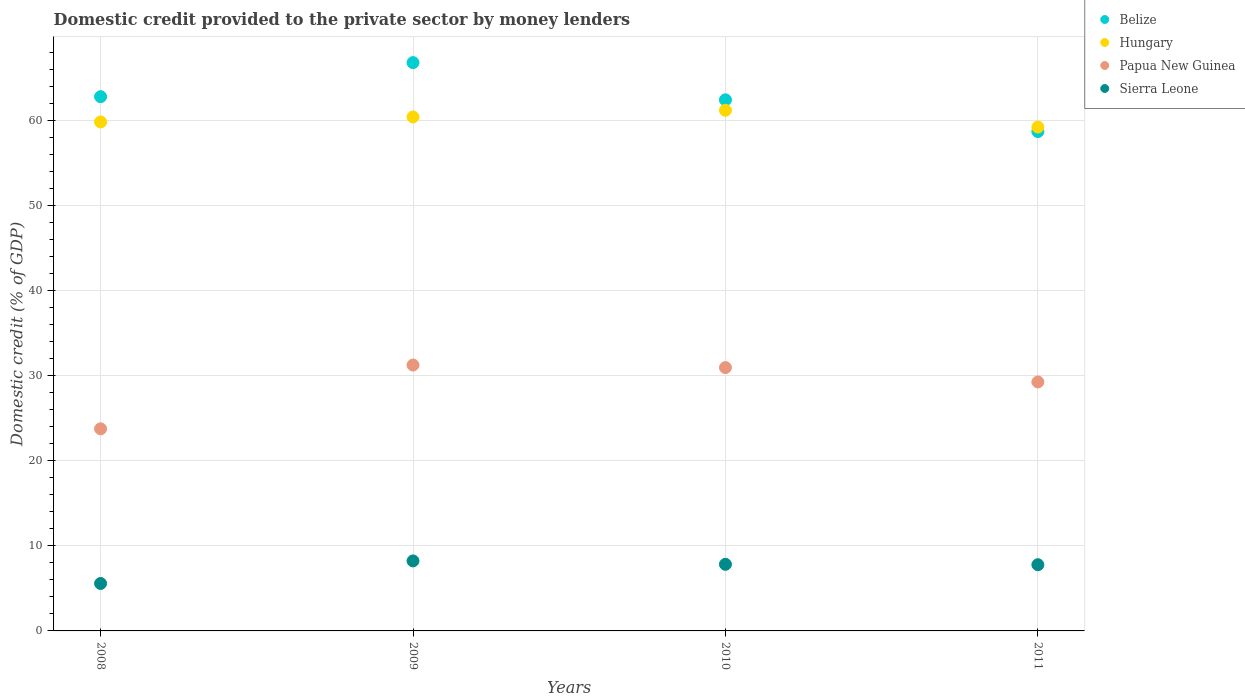What is the domestic credit provided to the private sector by money lenders in Hungary in 2008?
Offer a terse response. 59.79. Across all years, what is the maximum domestic credit provided to the private sector by money lenders in Hungary?
Provide a short and direct response. 61.16. Across all years, what is the minimum domestic credit provided to the private sector by money lenders in Sierra Leone?
Provide a short and direct response. 5.57. What is the total domestic credit provided to the private sector by money lenders in Papua New Guinea in the graph?
Provide a short and direct response. 115.15. What is the difference between the domestic credit provided to the private sector by money lenders in Hungary in 2008 and that in 2011?
Keep it short and to the point. 0.6. What is the difference between the domestic credit provided to the private sector by money lenders in Belize in 2011 and the domestic credit provided to the private sector by money lenders in Hungary in 2008?
Keep it short and to the point. -1.13. What is the average domestic credit provided to the private sector by money lenders in Hungary per year?
Your response must be concise. 60.13. In the year 2008, what is the difference between the domestic credit provided to the private sector by money lenders in Belize and domestic credit provided to the private sector by money lenders in Sierra Leone?
Keep it short and to the point. 57.18. What is the ratio of the domestic credit provided to the private sector by money lenders in Belize in 2009 to that in 2010?
Offer a very short reply. 1.07. Is the domestic credit provided to the private sector by money lenders in Papua New Guinea in 2010 less than that in 2011?
Your answer should be very brief. No. What is the difference between the highest and the second highest domestic credit provided to the private sector by money lenders in Belize?
Your response must be concise. 4. What is the difference between the highest and the lowest domestic credit provided to the private sector by money lenders in Hungary?
Your answer should be compact. 1.97. In how many years, is the domestic credit provided to the private sector by money lenders in Belize greater than the average domestic credit provided to the private sector by money lenders in Belize taken over all years?
Your response must be concise. 2. Is it the case that in every year, the sum of the domestic credit provided to the private sector by money lenders in Belize and domestic credit provided to the private sector by money lenders in Sierra Leone  is greater than the domestic credit provided to the private sector by money lenders in Hungary?
Ensure brevity in your answer.  Yes. Does the domestic credit provided to the private sector by money lenders in Papua New Guinea monotonically increase over the years?
Ensure brevity in your answer.  No. Is the domestic credit provided to the private sector by money lenders in Hungary strictly greater than the domestic credit provided to the private sector by money lenders in Papua New Guinea over the years?
Keep it short and to the point. Yes. Is the domestic credit provided to the private sector by money lenders in Sierra Leone strictly less than the domestic credit provided to the private sector by money lenders in Papua New Guinea over the years?
Offer a terse response. Yes. What is the difference between two consecutive major ticks on the Y-axis?
Offer a terse response. 10. Does the graph contain any zero values?
Your answer should be very brief. No. Does the graph contain grids?
Offer a very short reply. Yes. How many legend labels are there?
Provide a succinct answer. 4. What is the title of the graph?
Provide a succinct answer. Domestic credit provided to the private sector by money lenders. What is the label or title of the Y-axis?
Your answer should be compact. Domestic credit (% of GDP). What is the Domestic credit (% of GDP) of Belize in 2008?
Offer a terse response. 62.76. What is the Domestic credit (% of GDP) in Hungary in 2008?
Keep it short and to the point. 59.79. What is the Domestic credit (% of GDP) of Papua New Guinea in 2008?
Your answer should be compact. 23.74. What is the Domestic credit (% of GDP) in Sierra Leone in 2008?
Your response must be concise. 5.57. What is the Domestic credit (% of GDP) of Belize in 2009?
Ensure brevity in your answer.  66.76. What is the Domestic credit (% of GDP) in Hungary in 2009?
Your answer should be compact. 60.38. What is the Domestic credit (% of GDP) in Papua New Guinea in 2009?
Ensure brevity in your answer.  31.23. What is the Domestic credit (% of GDP) in Sierra Leone in 2009?
Offer a terse response. 8.22. What is the Domestic credit (% of GDP) of Belize in 2010?
Ensure brevity in your answer.  62.39. What is the Domestic credit (% of GDP) of Hungary in 2010?
Provide a succinct answer. 61.16. What is the Domestic credit (% of GDP) in Papua New Guinea in 2010?
Make the answer very short. 30.94. What is the Domestic credit (% of GDP) of Sierra Leone in 2010?
Keep it short and to the point. 7.82. What is the Domestic credit (% of GDP) in Belize in 2011?
Offer a very short reply. 58.66. What is the Domestic credit (% of GDP) of Hungary in 2011?
Provide a succinct answer. 59.19. What is the Domestic credit (% of GDP) of Papua New Guinea in 2011?
Ensure brevity in your answer.  29.24. What is the Domestic credit (% of GDP) of Sierra Leone in 2011?
Offer a very short reply. 7.78. Across all years, what is the maximum Domestic credit (% of GDP) of Belize?
Make the answer very short. 66.76. Across all years, what is the maximum Domestic credit (% of GDP) of Hungary?
Your answer should be compact. 61.16. Across all years, what is the maximum Domestic credit (% of GDP) in Papua New Guinea?
Give a very brief answer. 31.23. Across all years, what is the maximum Domestic credit (% of GDP) in Sierra Leone?
Your response must be concise. 8.22. Across all years, what is the minimum Domestic credit (% of GDP) of Belize?
Provide a short and direct response. 58.66. Across all years, what is the minimum Domestic credit (% of GDP) in Hungary?
Ensure brevity in your answer.  59.19. Across all years, what is the minimum Domestic credit (% of GDP) in Papua New Guinea?
Provide a succinct answer. 23.74. Across all years, what is the minimum Domestic credit (% of GDP) of Sierra Leone?
Your answer should be very brief. 5.57. What is the total Domestic credit (% of GDP) of Belize in the graph?
Your answer should be compact. 250.56. What is the total Domestic credit (% of GDP) in Hungary in the graph?
Offer a terse response. 240.52. What is the total Domestic credit (% of GDP) in Papua New Guinea in the graph?
Provide a succinct answer. 115.15. What is the total Domestic credit (% of GDP) in Sierra Leone in the graph?
Offer a terse response. 29.4. What is the difference between the Domestic credit (% of GDP) in Belize in 2008 and that in 2009?
Provide a short and direct response. -4. What is the difference between the Domestic credit (% of GDP) in Hungary in 2008 and that in 2009?
Your answer should be compact. -0.59. What is the difference between the Domestic credit (% of GDP) of Papua New Guinea in 2008 and that in 2009?
Offer a very short reply. -7.49. What is the difference between the Domestic credit (% of GDP) of Sierra Leone in 2008 and that in 2009?
Give a very brief answer. -2.65. What is the difference between the Domestic credit (% of GDP) of Belize in 2008 and that in 2010?
Ensure brevity in your answer.  0.37. What is the difference between the Domestic credit (% of GDP) in Hungary in 2008 and that in 2010?
Provide a succinct answer. -1.37. What is the difference between the Domestic credit (% of GDP) in Papua New Guinea in 2008 and that in 2010?
Provide a succinct answer. -7.19. What is the difference between the Domestic credit (% of GDP) of Sierra Leone in 2008 and that in 2010?
Ensure brevity in your answer.  -2.25. What is the difference between the Domestic credit (% of GDP) in Belize in 2008 and that in 2011?
Your answer should be very brief. 4.1. What is the difference between the Domestic credit (% of GDP) in Hungary in 2008 and that in 2011?
Your response must be concise. 0.6. What is the difference between the Domestic credit (% of GDP) of Papua New Guinea in 2008 and that in 2011?
Your answer should be compact. -5.5. What is the difference between the Domestic credit (% of GDP) of Sierra Leone in 2008 and that in 2011?
Give a very brief answer. -2.2. What is the difference between the Domestic credit (% of GDP) in Belize in 2009 and that in 2010?
Keep it short and to the point. 4.37. What is the difference between the Domestic credit (% of GDP) of Hungary in 2009 and that in 2010?
Offer a very short reply. -0.78. What is the difference between the Domestic credit (% of GDP) in Papua New Guinea in 2009 and that in 2010?
Offer a very short reply. 0.3. What is the difference between the Domestic credit (% of GDP) of Sierra Leone in 2009 and that in 2010?
Keep it short and to the point. 0.4. What is the difference between the Domestic credit (% of GDP) of Belize in 2009 and that in 2011?
Give a very brief answer. 8.1. What is the difference between the Domestic credit (% of GDP) of Hungary in 2009 and that in 2011?
Offer a very short reply. 1.19. What is the difference between the Domestic credit (% of GDP) of Papua New Guinea in 2009 and that in 2011?
Give a very brief answer. 1.99. What is the difference between the Domestic credit (% of GDP) in Sierra Leone in 2009 and that in 2011?
Your answer should be compact. 0.45. What is the difference between the Domestic credit (% of GDP) of Belize in 2010 and that in 2011?
Provide a short and direct response. 3.73. What is the difference between the Domestic credit (% of GDP) of Hungary in 2010 and that in 2011?
Offer a very short reply. 1.97. What is the difference between the Domestic credit (% of GDP) in Papua New Guinea in 2010 and that in 2011?
Ensure brevity in your answer.  1.69. What is the difference between the Domestic credit (% of GDP) in Sierra Leone in 2010 and that in 2011?
Keep it short and to the point. 0.05. What is the difference between the Domestic credit (% of GDP) in Belize in 2008 and the Domestic credit (% of GDP) in Hungary in 2009?
Offer a terse response. 2.38. What is the difference between the Domestic credit (% of GDP) in Belize in 2008 and the Domestic credit (% of GDP) in Papua New Guinea in 2009?
Your answer should be very brief. 31.52. What is the difference between the Domestic credit (% of GDP) in Belize in 2008 and the Domestic credit (% of GDP) in Sierra Leone in 2009?
Provide a short and direct response. 54.53. What is the difference between the Domestic credit (% of GDP) in Hungary in 2008 and the Domestic credit (% of GDP) in Papua New Guinea in 2009?
Offer a very short reply. 28.56. What is the difference between the Domestic credit (% of GDP) of Hungary in 2008 and the Domestic credit (% of GDP) of Sierra Leone in 2009?
Provide a succinct answer. 51.56. What is the difference between the Domestic credit (% of GDP) in Papua New Guinea in 2008 and the Domestic credit (% of GDP) in Sierra Leone in 2009?
Provide a short and direct response. 15.52. What is the difference between the Domestic credit (% of GDP) in Belize in 2008 and the Domestic credit (% of GDP) in Hungary in 2010?
Your answer should be very brief. 1.6. What is the difference between the Domestic credit (% of GDP) of Belize in 2008 and the Domestic credit (% of GDP) of Papua New Guinea in 2010?
Your answer should be compact. 31.82. What is the difference between the Domestic credit (% of GDP) in Belize in 2008 and the Domestic credit (% of GDP) in Sierra Leone in 2010?
Make the answer very short. 54.93. What is the difference between the Domestic credit (% of GDP) of Hungary in 2008 and the Domestic credit (% of GDP) of Papua New Guinea in 2010?
Provide a short and direct response. 28.85. What is the difference between the Domestic credit (% of GDP) of Hungary in 2008 and the Domestic credit (% of GDP) of Sierra Leone in 2010?
Your response must be concise. 51.96. What is the difference between the Domestic credit (% of GDP) of Papua New Guinea in 2008 and the Domestic credit (% of GDP) of Sierra Leone in 2010?
Offer a terse response. 15.92. What is the difference between the Domestic credit (% of GDP) in Belize in 2008 and the Domestic credit (% of GDP) in Hungary in 2011?
Make the answer very short. 3.57. What is the difference between the Domestic credit (% of GDP) in Belize in 2008 and the Domestic credit (% of GDP) in Papua New Guinea in 2011?
Ensure brevity in your answer.  33.51. What is the difference between the Domestic credit (% of GDP) in Belize in 2008 and the Domestic credit (% of GDP) in Sierra Leone in 2011?
Your response must be concise. 54.98. What is the difference between the Domestic credit (% of GDP) in Hungary in 2008 and the Domestic credit (% of GDP) in Papua New Guinea in 2011?
Ensure brevity in your answer.  30.54. What is the difference between the Domestic credit (% of GDP) in Hungary in 2008 and the Domestic credit (% of GDP) in Sierra Leone in 2011?
Offer a very short reply. 52.01. What is the difference between the Domestic credit (% of GDP) in Papua New Guinea in 2008 and the Domestic credit (% of GDP) in Sierra Leone in 2011?
Your answer should be very brief. 15.96. What is the difference between the Domestic credit (% of GDP) in Belize in 2009 and the Domestic credit (% of GDP) in Hungary in 2010?
Your answer should be compact. 5.6. What is the difference between the Domestic credit (% of GDP) of Belize in 2009 and the Domestic credit (% of GDP) of Papua New Guinea in 2010?
Your answer should be compact. 35.82. What is the difference between the Domestic credit (% of GDP) of Belize in 2009 and the Domestic credit (% of GDP) of Sierra Leone in 2010?
Offer a very short reply. 58.94. What is the difference between the Domestic credit (% of GDP) of Hungary in 2009 and the Domestic credit (% of GDP) of Papua New Guinea in 2010?
Make the answer very short. 29.44. What is the difference between the Domestic credit (% of GDP) in Hungary in 2009 and the Domestic credit (% of GDP) in Sierra Leone in 2010?
Keep it short and to the point. 52.56. What is the difference between the Domestic credit (% of GDP) of Papua New Guinea in 2009 and the Domestic credit (% of GDP) of Sierra Leone in 2010?
Your response must be concise. 23.41. What is the difference between the Domestic credit (% of GDP) of Belize in 2009 and the Domestic credit (% of GDP) of Hungary in 2011?
Your answer should be compact. 7.57. What is the difference between the Domestic credit (% of GDP) in Belize in 2009 and the Domestic credit (% of GDP) in Papua New Guinea in 2011?
Offer a terse response. 37.51. What is the difference between the Domestic credit (% of GDP) of Belize in 2009 and the Domestic credit (% of GDP) of Sierra Leone in 2011?
Ensure brevity in your answer.  58.98. What is the difference between the Domestic credit (% of GDP) of Hungary in 2009 and the Domestic credit (% of GDP) of Papua New Guinea in 2011?
Give a very brief answer. 31.14. What is the difference between the Domestic credit (% of GDP) in Hungary in 2009 and the Domestic credit (% of GDP) in Sierra Leone in 2011?
Your answer should be compact. 52.6. What is the difference between the Domestic credit (% of GDP) of Papua New Guinea in 2009 and the Domestic credit (% of GDP) of Sierra Leone in 2011?
Make the answer very short. 23.46. What is the difference between the Domestic credit (% of GDP) in Belize in 2010 and the Domestic credit (% of GDP) in Hungary in 2011?
Provide a short and direct response. 3.19. What is the difference between the Domestic credit (% of GDP) of Belize in 2010 and the Domestic credit (% of GDP) of Papua New Guinea in 2011?
Give a very brief answer. 33.14. What is the difference between the Domestic credit (% of GDP) of Belize in 2010 and the Domestic credit (% of GDP) of Sierra Leone in 2011?
Keep it short and to the point. 54.61. What is the difference between the Domestic credit (% of GDP) in Hungary in 2010 and the Domestic credit (% of GDP) in Papua New Guinea in 2011?
Your answer should be compact. 31.91. What is the difference between the Domestic credit (% of GDP) in Hungary in 2010 and the Domestic credit (% of GDP) in Sierra Leone in 2011?
Your response must be concise. 53.38. What is the difference between the Domestic credit (% of GDP) of Papua New Guinea in 2010 and the Domestic credit (% of GDP) of Sierra Leone in 2011?
Give a very brief answer. 23.16. What is the average Domestic credit (% of GDP) in Belize per year?
Offer a very short reply. 62.64. What is the average Domestic credit (% of GDP) of Hungary per year?
Offer a terse response. 60.13. What is the average Domestic credit (% of GDP) in Papua New Guinea per year?
Offer a terse response. 28.79. What is the average Domestic credit (% of GDP) in Sierra Leone per year?
Offer a very short reply. 7.35. In the year 2008, what is the difference between the Domestic credit (% of GDP) of Belize and Domestic credit (% of GDP) of Hungary?
Give a very brief answer. 2.97. In the year 2008, what is the difference between the Domestic credit (% of GDP) of Belize and Domestic credit (% of GDP) of Papua New Guinea?
Give a very brief answer. 39.02. In the year 2008, what is the difference between the Domestic credit (% of GDP) in Belize and Domestic credit (% of GDP) in Sierra Leone?
Give a very brief answer. 57.18. In the year 2008, what is the difference between the Domestic credit (% of GDP) of Hungary and Domestic credit (% of GDP) of Papua New Guinea?
Provide a succinct answer. 36.05. In the year 2008, what is the difference between the Domestic credit (% of GDP) of Hungary and Domestic credit (% of GDP) of Sierra Leone?
Provide a short and direct response. 54.21. In the year 2008, what is the difference between the Domestic credit (% of GDP) of Papua New Guinea and Domestic credit (% of GDP) of Sierra Leone?
Ensure brevity in your answer.  18.17. In the year 2009, what is the difference between the Domestic credit (% of GDP) of Belize and Domestic credit (% of GDP) of Hungary?
Your answer should be very brief. 6.38. In the year 2009, what is the difference between the Domestic credit (% of GDP) of Belize and Domestic credit (% of GDP) of Papua New Guinea?
Ensure brevity in your answer.  35.53. In the year 2009, what is the difference between the Domestic credit (% of GDP) of Belize and Domestic credit (% of GDP) of Sierra Leone?
Keep it short and to the point. 58.53. In the year 2009, what is the difference between the Domestic credit (% of GDP) of Hungary and Domestic credit (% of GDP) of Papua New Guinea?
Provide a succinct answer. 29.15. In the year 2009, what is the difference between the Domestic credit (% of GDP) in Hungary and Domestic credit (% of GDP) in Sierra Leone?
Your answer should be compact. 52.16. In the year 2009, what is the difference between the Domestic credit (% of GDP) in Papua New Guinea and Domestic credit (% of GDP) in Sierra Leone?
Offer a very short reply. 23.01. In the year 2010, what is the difference between the Domestic credit (% of GDP) of Belize and Domestic credit (% of GDP) of Hungary?
Your answer should be compact. 1.23. In the year 2010, what is the difference between the Domestic credit (% of GDP) in Belize and Domestic credit (% of GDP) in Papua New Guinea?
Ensure brevity in your answer.  31.45. In the year 2010, what is the difference between the Domestic credit (% of GDP) of Belize and Domestic credit (% of GDP) of Sierra Leone?
Provide a succinct answer. 54.56. In the year 2010, what is the difference between the Domestic credit (% of GDP) in Hungary and Domestic credit (% of GDP) in Papua New Guinea?
Your response must be concise. 30.22. In the year 2010, what is the difference between the Domestic credit (% of GDP) of Hungary and Domestic credit (% of GDP) of Sierra Leone?
Make the answer very short. 53.34. In the year 2010, what is the difference between the Domestic credit (% of GDP) of Papua New Guinea and Domestic credit (% of GDP) of Sierra Leone?
Your answer should be compact. 23.11. In the year 2011, what is the difference between the Domestic credit (% of GDP) of Belize and Domestic credit (% of GDP) of Hungary?
Your response must be concise. -0.53. In the year 2011, what is the difference between the Domestic credit (% of GDP) of Belize and Domestic credit (% of GDP) of Papua New Guinea?
Ensure brevity in your answer.  29.41. In the year 2011, what is the difference between the Domestic credit (% of GDP) of Belize and Domestic credit (% of GDP) of Sierra Leone?
Give a very brief answer. 50.88. In the year 2011, what is the difference between the Domestic credit (% of GDP) of Hungary and Domestic credit (% of GDP) of Papua New Guinea?
Provide a short and direct response. 29.95. In the year 2011, what is the difference between the Domestic credit (% of GDP) of Hungary and Domestic credit (% of GDP) of Sierra Leone?
Offer a terse response. 51.41. In the year 2011, what is the difference between the Domestic credit (% of GDP) in Papua New Guinea and Domestic credit (% of GDP) in Sierra Leone?
Offer a terse response. 21.47. What is the ratio of the Domestic credit (% of GDP) in Belize in 2008 to that in 2009?
Provide a succinct answer. 0.94. What is the ratio of the Domestic credit (% of GDP) of Hungary in 2008 to that in 2009?
Ensure brevity in your answer.  0.99. What is the ratio of the Domestic credit (% of GDP) of Papua New Guinea in 2008 to that in 2009?
Make the answer very short. 0.76. What is the ratio of the Domestic credit (% of GDP) in Sierra Leone in 2008 to that in 2009?
Offer a very short reply. 0.68. What is the ratio of the Domestic credit (% of GDP) of Hungary in 2008 to that in 2010?
Offer a terse response. 0.98. What is the ratio of the Domestic credit (% of GDP) in Papua New Guinea in 2008 to that in 2010?
Make the answer very short. 0.77. What is the ratio of the Domestic credit (% of GDP) of Sierra Leone in 2008 to that in 2010?
Provide a short and direct response. 0.71. What is the ratio of the Domestic credit (% of GDP) of Belize in 2008 to that in 2011?
Your answer should be compact. 1.07. What is the ratio of the Domestic credit (% of GDP) of Papua New Guinea in 2008 to that in 2011?
Provide a short and direct response. 0.81. What is the ratio of the Domestic credit (% of GDP) in Sierra Leone in 2008 to that in 2011?
Your answer should be very brief. 0.72. What is the ratio of the Domestic credit (% of GDP) in Belize in 2009 to that in 2010?
Your answer should be very brief. 1.07. What is the ratio of the Domestic credit (% of GDP) of Hungary in 2009 to that in 2010?
Keep it short and to the point. 0.99. What is the ratio of the Domestic credit (% of GDP) of Papua New Guinea in 2009 to that in 2010?
Ensure brevity in your answer.  1.01. What is the ratio of the Domestic credit (% of GDP) of Sierra Leone in 2009 to that in 2010?
Offer a terse response. 1.05. What is the ratio of the Domestic credit (% of GDP) in Belize in 2009 to that in 2011?
Offer a terse response. 1.14. What is the ratio of the Domestic credit (% of GDP) of Hungary in 2009 to that in 2011?
Your response must be concise. 1.02. What is the ratio of the Domestic credit (% of GDP) in Papua New Guinea in 2009 to that in 2011?
Your answer should be compact. 1.07. What is the ratio of the Domestic credit (% of GDP) in Sierra Leone in 2009 to that in 2011?
Keep it short and to the point. 1.06. What is the ratio of the Domestic credit (% of GDP) in Belize in 2010 to that in 2011?
Your answer should be compact. 1.06. What is the ratio of the Domestic credit (% of GDP) of Hungary in 2010 to that in 2011?
Your response must be concise. 1.03. What is the ratio of the Domestic credit (% of GDP) in Papua New Guinea in 2010 to that in 2011?
Your answer should be compact. 1.06. What is the ratio of the Domestic credit (% of GDP) of Sierra Leone in 2010 to that in 2011?
Your answer should be very brief. 1.01. What is the difference between the highest and the second highest Domestic credit (% of GDP) of Belize?
Ensure brevity in your answer.  4. What is the difference between the highest and the second highest Domestic credit (% of GDP) in Hungary?
Provide a short and direct response. 0.78. What is the difference between the highest and the second highest Domestic credit (% of GDP) of Papua New Guinea?
Provide a short and direct response. 0.3. What is the difference between the highest and the second highest Domestic credit (% of GDP) in Sierra Leone?
Offer a terse response. 0.4. What is the difference between the highest and the lowest Domestic credit (% of GDP) of Belize?
Ensure brevity in your answer.  8.1. What is the difference between the highest and the lowest Domestic credit (% of GDP) of Hungary?
Give a very brief answer. 1.97. What is the difference between the highest and the lowest Domestic credit (% of GDP) of Papua New Guinea?
Your answer should be very brief. 7.49. What is the difference between the highest and the lowest Domestic credit (% of GDP) in Sierra Leone?
Keep it short and to the point. 2.65. 